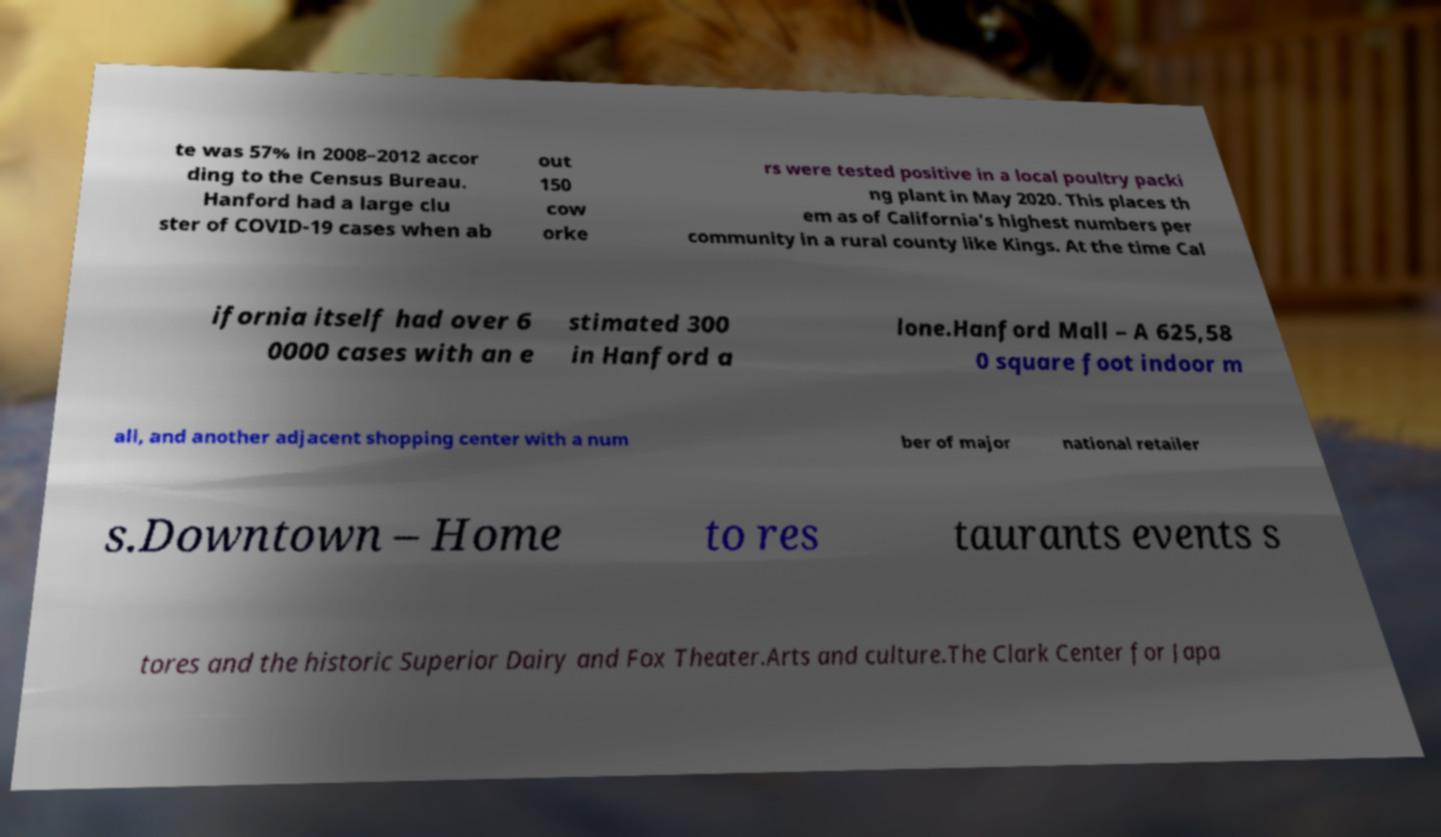Could you extract and type out the text from this image? te was 57% in 2008–2012 accor ding to the Census Bureau. Hanford had a large clu ster of COVID-19 cases when ab out 150 cow orke rs were tested positive in a local poultry packi ng plant in May 2020. This places th em as of California's highest numbers per community in a rural county like Kings. At the time Cal ifornia itself had over 6 0000 cases with an e stimated 300 in Hanford a lone.Hanford Mall – A 625,58 0 square foot indoor m all, and another adjacent shopping center with a num ber of major national retailer s.Downtown – Home to res taurants events s tores and the historic Superior Dairy and Fox Theater.Arts and culture.The Clark Center for Japa 